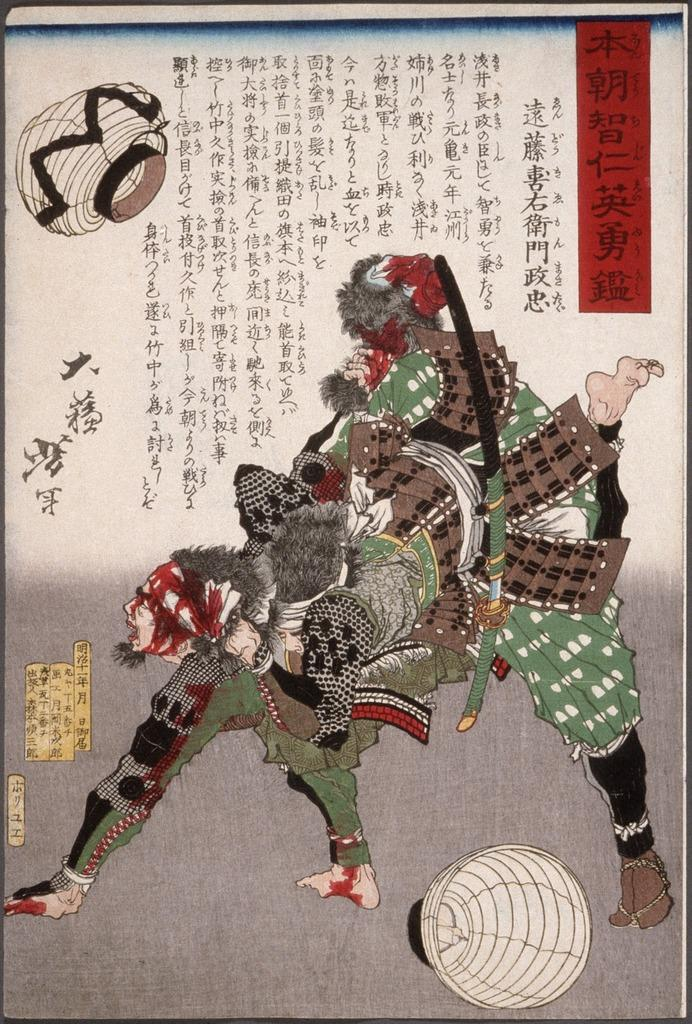What is present on the poster in the image? There is a poster in the image. What type of images are on the poster? There are people and figures depicted on the poster. What else can be seen on the poster besides the images? There is text present on the poster. What type of cream can be seen on the hands of the people depicted on the poster? There is no cream visible on the hands of the people depicted on the poster. What is the condition of the poster in the image? The condition of the poster cannot be determined from the image alone, as it only shows the poster and not its physical state. 